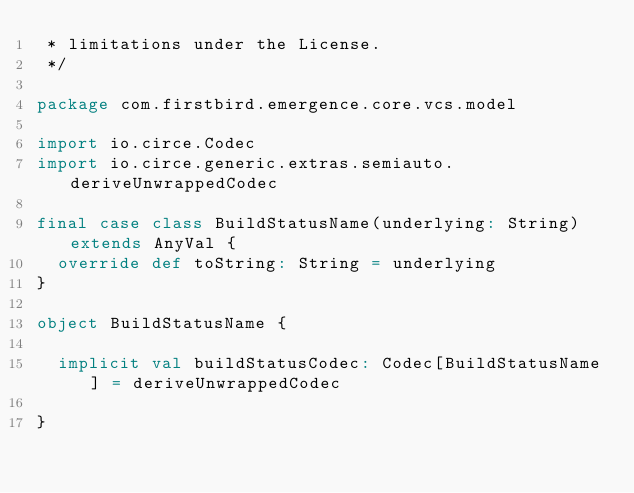Convert code to text. <code><loc_0><loc_0><loc_500><loc_500><_Scala_> * limitations under the License.
 */

package com.firstbird.emergence.core.vcs.model

import io.circe.Codec
import io.circe.generic.extras.semiauto.deriveUnwrappedCodec

final case class BuildStatusName(underlying: String) extends AnyVal {
  override def toString: String = underlying
}

object BuildStatusName {

  implicit val buildStatusCodec: Codec[BuildStatusName] = deriveUnwrappedCodec

}
</code> 